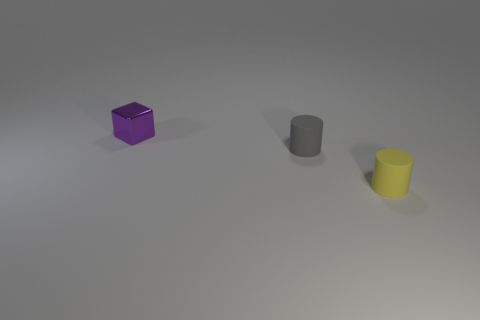There is a small object that is both behind the yellow matte object and in front of the purple metallic cube; what is it made of?
Your answer should be compact. Rubber. What number of metallic blocks are the same size as the purple thing?
Make the answer very short. 0. There is another object that is the same shape as the tiny gray matte thing; what material is it?
Offer a terse response. Rubber. How many objects are either objects on the left side of the tiny yellow thing or tiny objects that are on the right side of the tiny shiny cube?
Offer a very short reply. 3. There is a small yellow thing; is it the same shape as the small matte object behind the yellow thing?
Keep it short and to the point. Yes. What shape is the tiny rubber thing behind the object in front of the matte cylinder behind the small yellow rubber cylinder?
Your answer should be very brief. Cylinder. What number of other objects are the same material as the yellow cylinder?
Make the answer very short. 1. What number of objects are either small objects that are right of the purple metallic thing or small objects?
Your response must be concise. 3. The small object that is on the left side of the cylinder that is left of the yellow rubber object is what shape?
Provide a short and direct response. Cube. Is the shape of the small matte object behind the tiny yellow rubber thing the same as  the purple shiny thing?
Provide a succinct answer. No. 